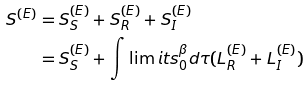Convert formula to latex. <formula><loc_0><loc_0><loc_500><loc_500>S ^ { ( E ) } & = S _ { S } ^ { ( E ) } + S _ { R } ^ { ( E ) } + S _ { I } ^ { ( E ) } \\ & = S _ { S } ^ { ( E ) } + \int \lim i t s _ { 0 } ^ { \beta } d \tau ( L _ { R } ^ { ( E ) } + L _ { I } ^ { ( E ) } )</formula> 